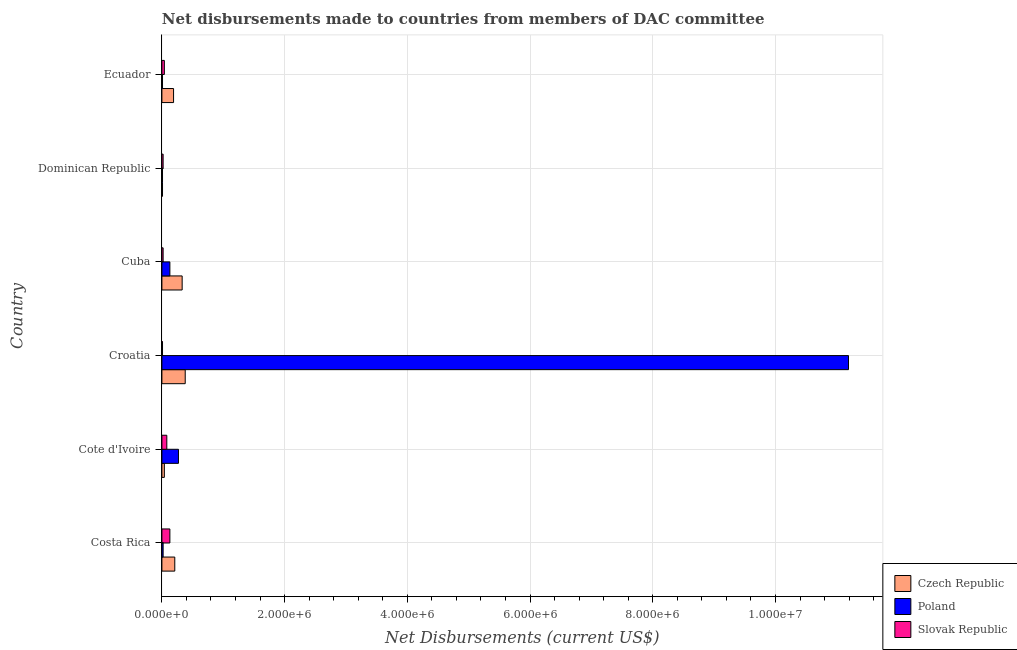Are the number of bars per tick equal to the number of legend labels?
Your answer should be very brief. Yes. Are the number of bars on each tick of the Y-axis equal?
Provide a short and direct response. Yes. How many bars are there on the 6th tick from the top?
Make the answer very short. 3. What is the label of the 3rd group of bars from the top?
Offer a very short reply. Cuba. In how many cases, is the number of bars for a given country not equal to the number of legend labels?
Your response must be concise. 0. What is the net disbursements made by czech republic in Ecuador?
Ensure brevity in your answer.  1.90e+05. Across all countries, what is the maximum net disbursements made by czech republic?
Provide a short and direct response. 3.80e+05. Across all countries, what is the minimum net disbursements made by czech republic?
Offer a terse response. 10000. In which country was the net disbursements made by czech republic maximum?
Ensure brevity in your answer.  Croatia. In which country was the net disbursements made by slovak republic minimum?
Give a very brief answer. Croatia. What is the total net disbursements made by slovak republic in the graph?
Offer a very short reply. 3.00e+05. What is the difference between the net disbursements made by slovak republic in Croatia and that in Dominican Republic?
Your response must be concise. -10000. What is the difference between the net disbursements made by poland in Croatia and the net disbursements made by czech republic in Cote d'Ivoire?
Your answer should be compact. 1.12e+07. What is the average net disbursements made by poland per country?
Make the answer very short. 1.94e+06. What is the difference between the net disbursements made by poland and net disbursements made by czech republic in Cuba?
Give a very brief answer. -2.00e+05. What is the ratio of the net disbursements made by poland in Cote d'Ivoire to that in Cuba?
Offer a terse response. 2.08. Is the net disbursements made by poland in Croatia less than that in Dominican Republic?
Provide a short and direct response. No. What is the difference between the highest and the second highest net disbursements made by poland?
Your answer should be compact. 1.09e+07. What is the difference between the highest and the lowest net disbursements made by poland?
Your answer should be very brief. 1.12e+07. What does the 3rd bar from the top in Cuba represents?
Make the answer very short. Czech Republic. What does the 2nd bar from the bottom in Dominican Republic represents?
Provide a short and direct response. Poland. Is it the case that in every country, the sum of the net disbursements made by czech republic and net disbursements made by poland is greater than the net disbursements made by slovak republic?
Offer a very short reply. No. Are all the bars in the graph horizontal?
Your answer should be compact. Yes. What is the difference between two consecutive major ticks on the X-axis?
Offer a terse response. 2.00e+06. Are the values on the major ticks of X-axis written in scientific E-notation?
Your answer should be compact. Yes. Does the graph contain any zero values?
Your answer should be compact. No. What is the title of the graph?
Ensure brevity in your answer.  Net disbursements made to countries from members of DAC committee. Does "Food" appear as one of the legend labels in the graph?
Your answer should be very brief. No. What is the label or title of the X-axis?
Your response must be concise. Net Disbursements (current US$). What is the Net Disbursements (current US$) of Czech Republic in Cote d'Ivoire?
Your answer should be very brief. 4.00e+04. What is the Net Disbursements (current US$) in Slovak Republic in Cote d'Ivoire?
Keep it short and to the point. 8.00e+04. What is the Net Disbursements (current US$) in Poland in Croatia?
Provide a succinct answer. 1.12e+07. What is the Net Disbursements (current US$) of Czech Republic in Cuba?
Give a very brief answer. 3.30e+05. What is the Net Disbursements (current US$) in Poland in Cuba?
Give a very brief answer. 1.30e+05. What is the Net Disbursements (current US$) of Slovak Republic in Cuba?
Provide a succinct answer. 2.00e+04. What is the Net Disbursements (current US$) of Poland in Ecuador?
Make the answer very short. 10000. What is the Net Disbursements (current US$) in Slovak Republic in Ecuador?
Your response must be concise. 4.00e+04. Across all countries, what is the maximum Net Disbursements (current US$) in Poland?
Your answer should be compact. 1.12e+07. Across all countries, what is the maximum Net Disbursements (current US$) of Slovak Republic?
Provide a succinct answer. 1.30e+05. Across all countries, what is the minimum Net Disbursements (current US$) in Poland?
Offer a terse response. 10000. What is the total Net Disbursements (current US$) of Czech Republic in the graph?
Your answer should be compact. 1.16e+06. What is the total Net Disbursements (current US$) in Poland in the graph?
Make the answer very short. 1.16e+07. What is the difference between the Net Disbursements (current US$) of Poland in Costa Rica and that in Cote d'Ivoire?
Offer a terse response. -2.50e+05. What is the difference between the Net Disbursements (current US$) in Slovak Republic in Costa Rica and that in Cote d'Ivoire?
Make the answer very short. 5.00e+04. What is the difference between the Net Disbursements (current US$) of Czech Republic in Costa Rica and that in Croatia?
Offer a terse response. -1.70e+05. What is the difference between the Net Disbursements (current US$) in Poland in Costa Rica and that in Croatia?
Provide a short and direct response. -1.12e+07. What is the difference between the Net Disbursements (current US$) of Poland in Costa Rica and that in Cuba?
Keep it short and to the point. -1.10e+05. What is the difference between the Net Disbursements (current US$) of Poland in Costa Rica and that in Dominican Republic?
Make the answer very short. 10000. What is the difference between the Net Disbursements (current US$) in Czech Republic in Costa Rica and that in Ecuador?
Offer a very short reply. 2.00e+04. What is the difference between the Net Disbursements (current US$) in Poland in Costa Rica and that in Ecuador?
Your answer should be compact. 10000. What is the difference between the Net Disbursements (current US$) in Poland in Cote d'Ivoire and that in Croatia?
Your response must be concise. -1.09e+07. What is the difference between the Net Disbursements (current US$) of Slovak Republic in Cote d'Ivoire and that in Croatia?
Provide a short and direct response. 7.00e+04. What is the difference between the Net Disbursements (current US$) of Czech Republic in Cote d'Ivoire and that in Cuba?
Give a very brief answer. -2.90e+05. What is the difference between the Net Disbursements (current US$) of Poland in Cote d'Ivoire and that in Cuba?
Make the answer very short. 1.40e+05. What is the difference between the Net Disbursements (current US$) in Slovak Republic in Cote d'Ivoire and that in Cuba?
Your answer should be compact. 6.00e+04. What is the difference between the Net Disbursements (current US$) of Slovak Republic in Cote d'Ivoire and that in Dominican Republic?
Give a very brief answer. 6.00e+04. What is the difference between the Net Disbursements (current US$) of Czech Republic in Cote d'Ivoire and that in Ecuador?
Offer a terse response. -1.50e+05. What is the difference between the Net Disbursements (current US$) of Slovak Republic in Cote d'Ivoire and that in Ecuador?
Provide a succinct answer. 4.00e+04. What is the difference between the Net Disbursements (current US$) in Czech Republic in Croatia and that in Cuba?
Provide a short and direct response. 5.00e+04. What is the difference between the Net Disbursements (current US$) in Poland in Croatia and that in Cuba?
Your answer should be very brief. 1.11e+07. What is the difference between the Net Disbursements (current US$) in Poland in Croatia and that in Dominican Republic?
Your answer should be very brief. 1.12e+07. What is the difference between the Net Disbursements (current US$) in Slovak Republic in Croatia and that in Dominican Republic?
Give a very brief answer. -10000. What is the difference between the Net Disbursements (current US$) in Poland in Croatia and that in Ecuador?
Your response must be concise. 1.12e+07. What is the difference between the Net Disbursements (current US$) of Czech Republic in Cuba and that in Dominican Republic?
Ensure brevity in your answer.  3.20e+05. What is the difference between the Net Disbursements (current US$) in Slovak Republic in Cuba and that in Dominican Republic?
Make the answer very short. 0. What is the difference between the Net Disbursements (current US$) of Poland in Cuba and that in Ecuador?
Keep it short and to the point. 1.20e+05. What is the difference between the Net Disbursements (current US$) in Slovak Republic in Cuba and that in Ecuador?
Make the answer very short. -2.00e+04. What is the difference between the Net Disbursements (current US$) in Czech Republic in Costa Rica and the Net Disbursements (current US$) in Poland in Cote d'Ivoire?
Your answer should be very brief. -6.00e+04. What is the difference between the Net Disbursements (current US$) in Czech Republic in Costa Rica and the Net Disbursements (current US$) in Poland in Croatia?
Keep it short and to the point. -1.10e+07. What is the difference between the Net Disbursements (current US$) in Czech Republic in Costa Rica and the Net Disbursements (current US$) in Slovak Republic in Croatia?
Give a very brief answer. 2.00e+05. What is the difference between the Net Disbursements (current US$) in Poland in Costa Rica and the Net Disbursements (current US$) in Slovak Republic in Croatia?
Provide a short and direct response. 10000. What is the difference between the Net Disbursements (current US$) in Czech Republic in Costa Rica and the Net Disbursements (current US$) in Slovak Republic in Cuba?
Make the answer very short. 1.90e+05. What is the difference between the Net Disbursements (current US$) of Czech Republic in Costa Rica and the Net Disbursements (current US$) of Poland in Ecuador?
Provide a succinct answer. 2.00e+05. What is the difference between the Net Disbursements (current US$) in Czech Republic in Costa Rica and the Net Disbursements (current US$) in Slovak Republic in Ecuador?
Provide a short and direct response. 1.70e+05. What is the difference between the Net Disbursements (current US$) of Poland in Costa Rica and the Net Disbursements (current US$) of Slovak Republic in Ecuador?
Your answer should be compact. -2.00e+04. What is the difference between the Net Disbursements (current US$) of Czech Republic in Cote d'Ivoire and the Net Disbursements (current US$) of Poland in Croatia?
Ensure brevity in your answer.  -1.12e+07. What is the difference between the Net Disbursements (current US$) of Czech Republic in Cote d'Ivoire and the Net Disbursements (current US$) of Slovak Republic in Cuba?
Ensure brevity in your answer.  2.00e+04. What is the difference between the Net Disbursements (current US$) in Czech Republic in Cote d'Ivoire and the Net Disbursements (current US$) in Poland in Dominican Republic?
Offer a very short reply. 3.00e+04. What is the difference between the Net Disbursements (current US$) of Czech Republic in Cote d'Ivoire and the Net Disbursements (current US$) of Slovak Republic in Dominican Republic?
Provide a succinct answer. 2.00e+04. What is the difference between the Net Disbursements (current US$) in Poland in Cote d'Ivoire and the Net Disbursements (current US$) in Slovak Republic in Dominican Republic?
Offer a terse response. 2.50e+05. What is the difference between the Net Disbursements (current US$) of Poland in Cote d'Ivoire and the Net Disbursements (current US$) of Slovak Republic in Ecuador?
Keep it short and to the point. 2.30e+05. What is the difference between the Net Disbursements (current US$) in Czech Republic in Croatia and the Net Disbursements (current US$) in Poland in Cuba?
Your response must be concise. 2.50e+05. What is the difference between the Net Disbursements (current US$) of Czech Republic in Croatia and the Net Disbursements (current US$) of Slovak Republic in Cuba?
Keep it short and to the point. 3.60e+05. What is the difference between the Net Disbursements (current US$) of Poland in Croatia and the Net Disbursements (current US$) of Slovak Republic in Cuba?
Ensure brevity in your answer.  1.12e+07. What is the difference between the Net Disbursements (current US$) of Czech Republic in Croatia and the Net Disbursements (current US$) of Poland in Dominican Republic?
Provide a short and direct response. 3.70e+05. What is the difference between the Net Disbursements (current US$) in Poland in Croatia and the Net Disbursements (current US$) in Slovak Republic in Dominican Republic?
Offer a terse response. 1.12e+07. What is the difference between the Net Disbursements (current US$) of Czech Republic in Croatia and the Net Disbursements (current US$) of Poland in Ecuador?
Make the answer very short. 3.70e+05. What is the difference between the Net Disbursements (current US$) in Czech Republic in Croatia and the Net Disbursements (current US$) in Slovak Republic in Ecuador?
Your answer should be compact. 3.40e+05. What is the difference between the Net Disbursements (current US$) of Poland in Croatia and the Net Disbursements (current US$) of Slovak Republic in Ecuador?
Your answer should be compact. 1.12e+07. What is the difference between the Net Disbursements (current US$) of Czech Republic in Cuba and the Net Disbursements (current US$) of Poland in Dominican Republic?
Your answer should be very brief. 3.20e+05. What is the difference between the Net Disbursements (current US$) of Poland in Cuba and the Net Disbursements (current US$) of Slovak Republic in Dominican Republic?
Make the answer very short. 1.10e+05. What is the difference between the Net Disbursements (current US$) of Czech Republic in Cuba and the Net Disbursements (current US$) of Poland in Ecuador?
Provide a succinct answer. 3.20e+05. What is the average Net Disbursements (current US$) in Czech Republic per country?
Your answer should be compact. 1.93e+05. What is the average Net Disbursements (current US$) of Poland per country?
Provide a short and direct response. 1.94e+06. What is the average Net Disbursements (current US$) in Slovak Republic per country?
Ensure brevity in your answer.  5.00e+04. What is the difference between the Net Disbursements (current US$) in Poland and Net Disbursements (current US$) in Slovak Republic in Costa Rica?
Offer a very short reply. -1.10e+05. What is the difference between the Net Disbursements (current US$) of Czech Republic and Net Disbursements (current US$) of Poland in Cote d'Ivoire?
Give a very brief answer. -2.30e+05. What is the difference between the Net Disbursements (current US$) in Czech Republic and Net Disbursements (current US$) in Slovak Republic in Cote d'Ivoire?
Your answer should be compact. -4.00e+04. What is the difference between the Net Disbursements (current US$) in Czech Republic and Net Disbursements (current US$) in Poland in Croatia?
Offer a terse response. -1.08e+07. What is the difference between the Net Disbursements (current US$) of Poland and Net Disbursements (current US$) of Slovak Republic in Croatia?
Offer a terse response. 1.12e+07. What is the difference between the Net Disbursements (current US$) of Czech Republic and Net Disbursements (current US$) of Poland in Cuba?
Your response must be concise. 2.00e+05. What is the difference between the Net Disbursements (current US$) in Poland and Net Disbursements (current US$) in Slovak Republic in Cuba?
Offer a terse response. 1.10e+05. What is the difference between the Net Disbursements (current US$) of Czech Republic and Net Disbursements (current US$) of Poland in Dominican Republic?
Give a very brief answer. 0. What is the difference between the Net Disbursements (current US$) of Czech Republic and Net Disbursements (current US$) of Poland in Ecuador?
Your answer should be compact. 1.80e+05. What is the difference between the Net Disbursements (current US$) in Czech Republic and Net Disbursements (current US$) in Slovak Republic in Ecuador?
Your answer should be compact. 1.50e+05. What is the ratio of the Net Disbursements (current US$) in Czech Republic in Costa Rica to that in Cote d'Ivoire?
Your answer should be compact. 5.25. What is the ratio of the Net Disbursements (current US$) in Poland in Costa Rica to that in Cote d'Ivoire?
Make the answer very short. 0.07. What is the ratio of the Net Disbursements (current US$) of Slovak Republic in Costa Rica to that in Cote d'Ivoire?
Keep it short and to the point. 1.62. What is the ratio of the Net Disbursements (current US$) in Czech Republic in Costa Rica to that in Croatia?
Keep it short and to the point. 0.55. What is the ratio of the Net Disbursements (current US$) in Poland in Costa Rica to that in Croatia?
Offer a terse response. 0. What is the ratio of the Net Disbursements (current US$) in Slovak Republic in Costa Rica to that in Croatia?
Provide a succinct answer. 13. What is the ratio of the Net Disbursements (current US$) of Czech Republic in Costa Rica to that in Cuba?
Your answer should be very brief. 0.64. What is the ratio of the Net Disbursements (current US$) of Poland in Costa Rica to that in Cuba?
Offer a terse response. 0.15. What is the ratio of the Net Disbursements (current US$) of Slovak Republic in Costa Rica to that in Cuba?
Give a very brief answer. 6.5. What is the ratio of the Net Disbursements (current US$) in Poland in Costa Rica to that in Dominican Republic?
Offer a very short reply. 2. What is the ratio of the Net Disbursements (current US$) in Czech Republic in Costa Rica to that in Ecuador?
Ensure brevity in your answer.  1.11. What is the ratio of the Net Disbursements (current US$) in Poland in Costa Rica to that in Ecuador?
Ensure brevity in your answer.  2. What is the ratio of the Net Disbursements (current US$) of Slovak Republic in Costa Rica to that in Ecuador?
Ensure brevity in your answer.  3.25. What is the ratio of the Net Disbursements (current US$) in Czech Republic in Cote d'Ivoire to that in Croatia?
Your response must be concise. 0.11. What is the ratio of the Net Disbursements (current US$) of Poland in Cote d'Ivoire to that in Croatia?
Ensure brevity in your answer.  0.02. What is the ratio of the Net Disbursements (current US$) in Czech Republic in Cote d'Ivoire to that in Cuba?
Your answer should be compact. 0.12. What is the ratio of the Net Disbursements (current US$) in Poland in Cote d'Ivoire to that in Cuba?
Your answer should be very brief. 2.08. What is the ratio of the Net Disbursements (current US$) of Czech Republic in Cote d'Ivoire to that in Dominican Republic?
Give a very brief answer. 4. What is the ratio of the Net Disbursements (current US$) in Czech Republic in Cote d'Ivoire to that in Ecuador?
Give a very brief answer. 0.21. What is the ratio of the Net Disbursements (current US$) of Poland in Cote d'Ivoire to that in Ecuador?
Offer a terse response. 27. What is the ratio of the Net Disbursements (current US$) in Slovak Republic in Cote d'Ivoire to that in Ecuador?
Offer a very short reply. 2. What is the ratio of the Net Disbursements (current US$) of Czech Republic in Croatia to that in Cuba?
Offer a terse response. 1.15. What is the ratio of the Net Disbursements (current US$) in Poland in Croatia to that in Cuba?
Keep it short and to the point. 86.08. What is the ratio of the Net Disbursements (current US$) of Poland in Croatia to that in Dominican Republic?
Provide a succinct answer. 1119. What is the ratio of the Net Disbursements (current US$) of Poland in Croatia to that in Ecuador?
Provide a short and direct response. 1119. What is the ratio of the Net Disbursements (current US$) of Slovak Republic in Croatia to that in Ecuador?
Your answer should be compact. 0.25. What is the ratio of the Net Disbursements (current US$) in Czech Republic in Cuba to that in Dominican Republic?
Keep it short and to the point. 33. What is the ratio of the Net Disbursements (current US$) in Poland in Cuba to that in Dominican Republic?
Give a very brief answer. 13. What is the ratio of the Net Disbursements (current US$) in Czech Republic in Cuba to that in Ecuador?
Keep it short and to the point. 1.74. What is the ratio of the Net Disbursements (current US$) in Poland in Cuba to that in Ecuador?
Give a very brief answer. 13. What is the ratio of the Net Disbursements (current US$) of Czech Republic in Dominican Republic to that in Ecuador?
Offer a terse response. 0.05. What is the ratio of the Net Disbursements (current US$) in Slovak Republic in Dominican Republic to that in Ecuador?
Offer a very short reply. 0.5. What is the difference between the highest and the second highest Net Disbursements (current US$) in Czech Republic?
Your response must be concise. 5.00e+04. What is the difference between the highest and the second highest Net Disbursements (current US$) of Poland?
Your answer should be very brief. 1.09e+07. What is the difference between the highest and the lowest Net Disbursements (current US$) of Czech Republic?
Offer a terse response. 3.70e+05. What is the difference between the highest and the lowest Net Disbursements (current US$) in Poland?
Your response must be concise. 1.12e+07. What is the difference between the highest and the lowest Net Disbursements (current US$) in Slovak Republic?
Your answer should be very brief. 1.20e+05. 